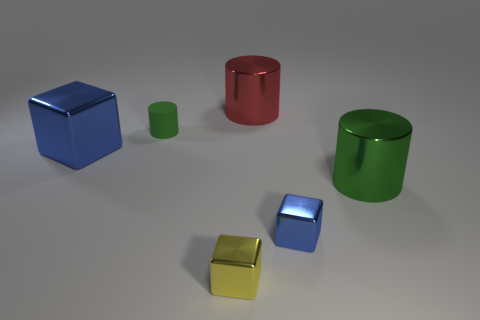Are there any green shiny cylinders on the left side of the large cylinder in front of the large red cylinder?
Your answer should be very brief. No. What number of blocks are either metallic objects or small green objects?
Make the answer very short. 3. There is a green cylinder left of the blue metallic cube to the right of the green object that is on the left side of the large red shiny object; how big is it?
Your answer should be very brief. Small. Are there any metallic cubes right of the red shiny cylinder?
Give a very brief answer. Yes. What shape is the object that is the same color as the large metallic cube?
Make the answer very short. Cube. How many things are big metal cylinders that are behind the green metal object or small red metal objects?
Ensure brevity in your answer.  1. There is a yellow thing that is made of the same material as the big cube; what size is it?
Give a very brief answer. Small. There is a red metallic cylinder; does it have the same size as the green cylinder behind the large block?
Provide a short and direct response. No. There is a large metallic object that is both to the right of the tiny green cylinder and in front of the tiny rubber object; what is its color?
Provide a short and direct response. Green. How many things are either blue shiny things that are right of the yellow metal cube or blue things that are in front of the big green cylinder?
Offer a terse response. 1. 